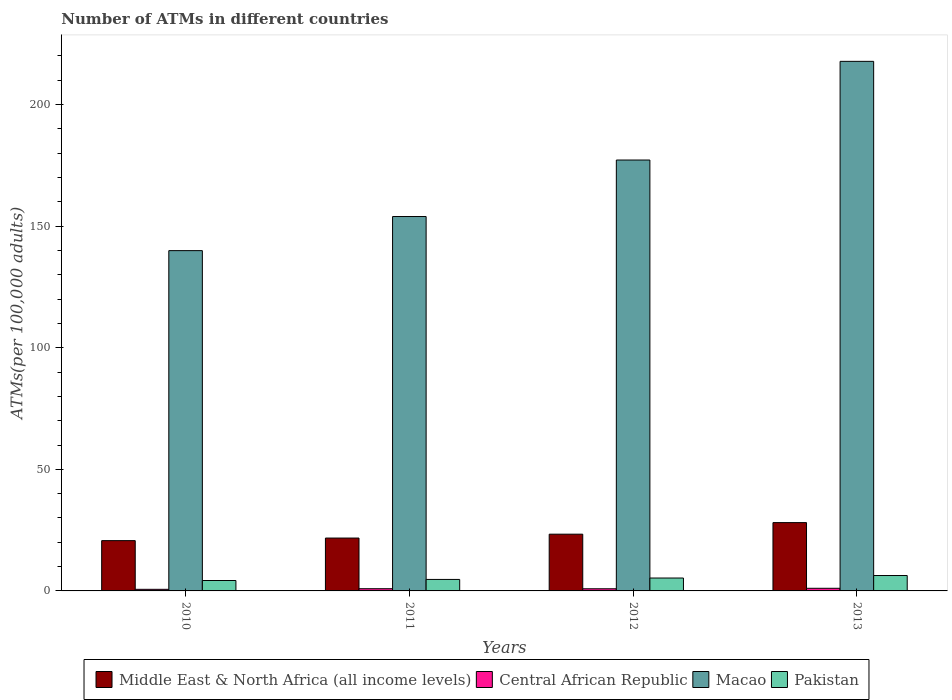How many different coloured bars are there?
Your response must be concise. 4. How many groups of bars are there?
Offer a terse response. 4. Are the number of bars per tick equal to the number of legend labels?
Offer a terse response. Yes. Are the number of bars on each tick of the X-axis equal?
Give a very brief answer. Yes. How many bars are there on the 4th tick from the left?
Give a very brief answer. 4. What is the label of the 2nd group of bars from the left?
Offer a very short reply. 2011. What is the number of ATMs in Pakistan in 2011?
Your response must be concise. 4.73. Across all years, what is the maximum number of ATMs in Central African Republic?
Provide a short and direct response. 1.08. Across all years, what is the minimum number of ATMs in Middle East & North Africa (all income levels)?
Keep it short and to the point. 20.68. In which year was the number of ATMs in Pakistan minimum?
Keep it short and to the point. 2010. What is the total number of ATMs in Central African Republic in the graph?
Make the answer very short. 3.53. What is the difference between the number of ATMs in Central African Republic in 2011 and that in 2012?
Give a very brief answer. 0.02. What is the difference between the number of ATMs in Central African Republic in 2011 and the number of ATMs in Pakistan in 2012?
Provide a short and direct response. -4.4. What is the average number of ATMs in Pakistan per year?
Offer a terse response. 5.16. In the year 2013, what is the difference between the number of ATMs in Middle East & North Africa (all income levels) and number of ATMs in Macao?
Provide a short and direct response. -189.7. In how many years, is the number of ATMs in Middle East & North Africa (all income levels) greater than 180?
Give a very brief answer. 0. What is the ratio of the number of ATMs in Central African Republic in 2010 to that in 2012?
Your response must be concise. 0.74. Is the number of ATMs in Central African Republic in 2011 less than that in 2012?
Keep it short and to the point. No. Is the difference between the number of ATMs in Middle East & North Africa (all income levels) in 2010 and 2012 greater than the difference between the number of ATMs in Macao in 2010 and 2012?
Provide a succinct answer. Yes. What is the difference between the highest and the second highest number of ATMs in Central African Republic?
Provide a succinct answer. 0.17. What is the difference between the highest and the lowest number of ATMs in Central African Republic?
Your response must be concise. 0.42. Is the sum of the number of ATMs in Central African Republic in 2010 and 2011 greater than the maximum number of ATMs in Pakistan across all years?
Make the answer very short. No. What does the 3rd bar from the left in 2013 represents?
Your answer should be compact. Macao. Are all the bars in the graph horizontal?
Provide a short and direct response. No. What is the difference between two consecutive major ticks on the Y-axis?
Offer a terse response. 50. Are the values on the major ticks of Y-axis written in scientific E-notation?
Ensure brevity in your answer.  No. Does the graph contain any zero values?
Provide a succinct answer. No. Where does the legend appear in the graph?
Your response must be concise. Bottom center. How many legend labels are there?
Your answer should be very brief. 4. What is the title of the graph?
Your answer should be compact. Number of ATMs in different countries. Does "Equatorial Guinea" appear as one of the legend labels in the graph?
Make the answer very short. No. What is the label or title of the Y-axis?
Your answer should be compact. ATMs(per 100,0 adults). What is the ATMs(per 100,000 adults) of Middle East & North Africa (all income levels) in 2010?
Give a very brief answer. 20.68. What is the ATMs(per 100,000 adults) of Central African Republic in 2010?
Provide a short and direct response. 0.66. What is the ATMs(per 100,000 adults) in Macao in 2010?
Your answer should be very brief. 139.95. What is the ATMs(per 100,000 adults) in Pakistan in 2010?
Your answer should be compact. 4.28. What is the ATMs(per 100,000 adults) of Middle East & North Africa (all income levels) in 2011?
Keep it short and to the point. 21.74. What is the ATMs(per 100,000 adults) in Central African Republic in 2011?
Keep it short and to the point. 0.91. What is the ATMs(per 100,000 adults) in Macao in 2011?
Keep it short and to the point. 153.98. What is the ATMs(per 100,000 adults) of Pakistan in 2011?
Give a very brief answer. 4.73. What is the ATMs(per 100,000 adults) in Middle East & North Africa (all income levels) in 2012?
Your answer should be compact. 23.34. What is the ATMs(per 100,000 adults) of Central African Republic in 2012?
Offer a very short reply. 0.88. What is the ATMs(per 100,000 adults) in Macao in 2012?
Offer a terse response. 177.21. What is the ATMs(per 100,000 adults) of Pakistan in 2012?
Make the answer very short. 5.31. What is the ATMs(per 100,000 adults) of Middle East & North Africa (all income levels) in 2013?
Ensure brevity in your answer.  28.1. What is the ATMs(per 100,000 adults) of Central African Republic in 2013?
Ensure brevity in your answer.  1.08. What is the ATMs(per 100,000 adults) of Macao in 2013?
Offer a terse response. 217.79. What is the ATMs(per 100,000 adults) of Pakistan in 2013?
Offer a very short reply. 6.33. Across all years, what is the maximum ATMs(per 100,000 adults) in Middle East & North Africa (all income levels)?
Provide a succinct answer. 28.1. Across all years, what is the maximum ATMs(per 100,000 adults) in Central African Republic?
Your response must be concise. 1.08. Across all years, what is the maximum ATMs(per 100,000 adults) in Macao?
Provide a short and direct response. 217.79. Across all years, what is the maximum ATMs(per 100,000 adults) of Pakistan?
Offer a terse response. 6.33. Across all years, what is the minimum ATMs(per 100,000 adults) of Middle East & North Africa (all income levels)?
Your response must be concise. 20.68. Across all years, what is the minimum ATMs(per 100,000 adults) in Central African Republic?
Keep it short and to the point. 0.66. Across all years, what is the minimum ATMs(per 100,000 adults) of Macao?
Make the answer very short. 139.95. Across all years, what is the minimum ATMs(per 100,000 adults) in Pakistan?
Your response must be concise. 4.28. What is the total ATMs(per 100,000 adults) in Middle East & North Africa (all income levels) in the graph?
Your response must be concise. 93.86. What is the total ATMs(per 100,000 adults) in Central African Republic in the graph?
Your response must be concise. 3.53. What is the total ATMs(per 100,000 adults) in Macao in the graph?
Offer a terse response. 688.93. What is the total ATMs(per 100,000 adults) in Pakistan in the graph?
Your answer should be compact. 20.65. What is the difference between the ATMs(per 100,000 adults) of Middle East & North Africa (all income levels) in 2010 and that in 2011?
Give a very brief answer. -1.06. What is the difference between the ATMs(per 100,000 adults) of Central African Republic in 2010 and that in 2011?
Offer a terse response. -0.25. What is the difference between the ATMs(per 100,000 adults) of Macao in 2010 and that in 2011?
Offer a very short reply. -14.03. What is the difference between the ATMs(per 100,000 adults) in Pakistan in 2010 and that in 2011?
Offer a terse response. -0.45. What is the difference between the ATMs(per 100,000 adults) of Middle East & North Africa (all income levels) in 2010 and that in 2012?
Your answer should be very brief. -2.65. What is the difference between the ATMs(per 100,000 adults) in Central African Republic in 2010 and that in 2012?
Offer a terse response. -0.23. What is the difference between the ATMs(per 100,000 adults) of Macao in 2010 and that in 2012?
Make the answer very short. -37.27. What is the difference between the ATMs(per 100,000 adults) of Pakistan in 2010 and that in 2012?
Give a very brief answer. -1.02. What is the difference between the ATMs(per 100,000 adults) of Middle East & North Africa (all income levels) in 2010 and that in 2013?
Offer a terse response. -7.41. What is the difference between the ATMs(per 100,000 adults) of Central African Republic in 2010 and that in 2013?
Provide a succinct answer. -0.42. What is the difference between the ATMs(per 100,000 adults) of Macao in 2010 and that in 2013?
Your answer should be compact. -77.85. What is the difference between the ATMs(per 100,000 adults) of Pakistan in 2010 and that in 2013?
Offer a terse response. -2.05. What is the difference between the ATMs(per 100,000 adults) in Middle East & North Africa (all income levels) in 2011 and that in 2012?
Keep it short and to the point. -1.59. What is the difference between the ATMs(per 100,000 adults) of Central African Republic in 2011 and that in 2012?
Make the answer very short. 0.02. What is the difference between the ATMs(per 100,000 adults) in Macao in 2011 and that in 2012?
Provide a short and direct response. -23.24. What is the difference between the ATMs(per 100,000 adults) of Pakistan in 2011 and that in 2012?
Give a very brief answer. -0.58. What is the difference between the ATMs(per 100,000 adults) in Middle East & North Africa (all income levels) in 2011 and that in 2013?
Make the answer very short. -6.35. What is the difference between the ATMs(per 100,000 adults) in Central African Republic in 2011 and that in 2013?
Your answer should be compact. -0.17. What is the difference between the ATMs(per 100,000 adults) in Macao in 2011 and that in 2013?
Give a very brief answer. -63.82. What is the difference between the ATMs(per 100,000 adults) of Pakistan in 2011 and that in 2013?
Provide a succinct answer. -1.61. What is the difference between the ATMs(per 100,000 adults) of Middle East & North Africa (all income levels) in 2012 and that in 2013?
Provide a succinct answer. -4.76. What is the difference between the ATMs(per 100,000 adults) in Central African Republic in 2012 and that in 2013?
Provide a succinct answer. -0.2. What is the difference between the ATMs(per 100,000 adults) in Macao in 2012 and that in 2013?
Give a very brief answer. -40.58. What is the difference between the ATMs(per 100,000 adults) in Pakistan in 2012 and that in 2013?
Offer a very short reply. -1.03. What is the difference between the ATMs(per 100,000 adults) in Middle East & North Africa (all income levels) in 2010 and the ATMs(per 100,000 adults) in Central African Republic in 2011?
Provide a succinct answer. 19.78. What is the difference between the ATMs(per 100,000 adults) of Middle East & North Africa (all income levels) in 2010 and the ATMs(per 100,000 adults) of Macao in 2011?
Provide a short and direct response. -133.29. What is the difference between the ATMs(per 100,000 adults) in Middle East & North Africa (all income levels) in 2010 and the ATMs(per 100,000 adults) in Pakistan in 2011?
Offer a very short reply. 15.96. What is the difference between the ATMs(per 100,000 adults) of Central African Republic in 2010 and the ATMs(per 100,000 adults) of Macao in 2011?
Your answer should be compact. -153.32. What is the difference between the ATMs(per 100,000 adults) in Central African Republic in 2010 and the ATMs(per 100,000 adults) in Pakistan in 2011?
Provide a short and direct response. -4.07. What is the difference between the ATMs(per 100,000 adults) of Macao in 2010 and the ATMs(per 100,000 adults) of Pakistan in 2011?
Ensure brevity in your answer.  135.22. What is the difference between the ATMs(per 100,000 adults) of Middle East & North Africa (all income levels) in 2010 and the ATMs(per 100,000 adults) of Central African Republic in 2012?
Offer a very short reply. 19.8. What is the difference between the ATMs(per 100,000 adults) in Middle East & North Africa (all income levels) in 2010 and the ATMs(per 100,000 adults) in Macao in 2012?
Your answer should be compact. -156.53. What is the difference between the ATMs(per 100,000 adults) of Middle East & North Africa (all income levels) in 2010 and the ATMs(per 100,000 adults) of Pakistan in 2012?
Your response must be concise. 15.38. What is the difference between the ATMs(per 100,000 adults) in Central African Republic in 2010 and the ATMs(per 100,000 adults) in Macao in 2012?
Your answer should be compact. -176.56. What is the difference between the ATMs(per 100,000 adults) of Central African Republic in 2010 and the ATMs(per 100,000 adults) of Pakistan in 2012?
Provide a succinct answer. -4.65. What is the difference between the ATMs(per 100,000 adults) of Macao in 2010 and the ATMs(per 100,000 adults) of Pakistan in 2012?
Offer a very short reply. 134.64. What is the difference between the ATMs(per 100,000 adults) of Middle East & North Africa (all income levels) in 2010 and the ATMs(per 100,000 adults) of Central African Republic in 2013?
Provide a succinct answer. 19.6. What is the difference between the ATMs(per 100,000 adults) of Middle East & North Africa (all income levels) in 2010 and the ATMs(per 100,000 adults) of Macao in 2013?
Ensure brevity in your answer.  -197.11. What is the difference between the ATMs(per 100,000 adults) in Middle East & North Africa (all income levels) in 2010 and the ATMs(per 100,000 adults) in Pakistan in 2013?
Give a very brief answer. 14.35. What is the difference between the ATMs(per 100,000 adults) in Central African Republic in 2010 and the ATMs(per 100,000 adults) in Macao in 2013?
Give a very brief answer. -217.13. What is the difference between the ATMs(per 100,000 adults) in Central African Republic in 2010 and the ATMs(per 100,000 adults) in Pakistan in 2013?
Your answer should be very brief. -5.68. What is the difference between the ATMs(per 100,000 adults) in Macao in 2010 and the ATMs(per 100,000 adults) in Pakistan in 2013?
Give a very brief answer. 133.61. What is the difference between the ATMs(per 100,000 adults) in Middle East & North Africa (all income levels) in 2011 and the ATMs(per 100,000 adults) in Central African Republic in 2012?
Offer a terse response. 20.86. What is the difference between the ATMs(per 100,000 adults) of Middle East & North Africa (all income levels) in 2011 and the ATMs(per 100,000 adults) of Macao in 2012?
Your response must be concise. -155.47. What is the difference between the ATMs(per 100,000 adults) of Middle East & North Africa (all income levels) in 2011 and the ATMs(per 100,000 adults) of Pakistan in 2012?
Make the answer very short. 16.44. What is the difference between the ATMs(per 100,000 adults) in Central African Republic in 2011 and the ATMs(per 100,000 adults) in Macao in 2012?
Your response must be concise. -176.31. What is the difference between the ATMs(per 100,000 adults) of Central African Republic in 2011 and the ATMs(per 100,000 adults) of Pakistan in 2012?
Your response must be concise. -4.4. What is the difference between the ATMs(per 100,000 adults) in Macao in 2011 and the ATMs(per 100,000 adults) in Pakistan in 2012?
Provide a succinct answer. 148.67. What is the difference between the ATMs(per 100,000 adults) of Middle East & North Africa (all income levels) in 2011 and the ATMs(per 100,000 adults) of Central African Republic in 2013?
Provide a short and direct response. 20.66. What is the difference between the ATMs(per 100,000 adults) in Middle East & North Africa (all income levels) in 2011 and the ATMs(per 100,000 adults) in Macao in 2013?
Your answer should be compact. -196.05. What is the difference between the ATMs(per 100,000 adults) in Middle East & North Africa (all income levels) in 2011 and the ATMs(per 100,000 adults) in Pakistan in 2013?
Offer a terse response. 15.41. What is the difference between the ATMs(per 100,000 adults) in Central African Republic in 2011 and the ATMs(per 100,000 adults) in Macao in 2013?
Make the answer very short. -216.88. What is the difference between the ATMs(per 100,000 adults) of Central African Republic in 2011 and the ATMs(per 100,000 adults) of Pakistan in 2013?
Make the answer very short. -5.43. What is the difference between the ATMs(per 100,000 adults) in Macao in 2011 and the ATMs(per 100,000 adults) in Pakistan in 2013?
Make the answer very short. 147.64. What is the difference between the ATMs(per 100,000 adults) of Middle East & North Africa (all income levels) in 2012 and the ATMs(per 100,000 adults) of Central African Republic in 2013?
Your response must be concise. 22.26. What is the difference between the ATMs(per 100,000 adults) of Middle East & North Africa (all income levels) in 2012 and the ATMs(per 100,000 adults) of Macao in 2013?
Make the answer very short. -194.46. What is the difference between the ATMs(per 100,000 adults) in Middle East & North Africa (all income levels) in 2012 and the ATMs(per 100,000 adults) in Pakistan in 2013?
Ensure brevity in your answer.  17. What is the difference between the ATMs(per 100,000 adults) in Central African Republic in 2012 and the ATMs(per 100,000 adults) in Macao in 2013?
Your answer should be compact. -216.91. What is the difference between the ATMs(per 100,000 adults) in Central African Republic in 2012 and the ATMs(per 100,000 adults) in Pakistan in 2013?
Your answer should be very brief. -5.45. What is the difference between the ATMs(per 100,000 adults) of Macao in 2012 and the ATMs(per 100,000 adults) of Pakistan in 2013?
Make the answer very short. 170.88. What is the average ATMs(per 100,000 adults) of Middle East & North Africa (all income levels) per year?
Make the answer very short. 23.46. What is the average ATMs(per 100,000 adults) in Central African Republic per year?
Provide a succinct answer. 0.88. What is the average ATMs(per 100,000 adults) of Macao per year?
Give a very brief answer. 172.23. What is the average ATMs(per 100,000 adults) of Pakistan per year?
Provide a succinct answer. 5.16. In the year 2010, what is the difference between the ATMs(per 100,000 adults) in Middle East & North Africa (all income levels) and ATMs(per 100,000 adults) in Central African Republic?
Your response must be concise. 20.02. In the year 2010, what is the difference between the ATMs(per 100,000 adults) in Middle East & North Africa (all income levels) and ATMs(per 100,000 adults) in Macao?
Your answer should be very brief. -119.26. In the year 2010, what is the difference between the ATMs(per 100,000 adults) in Middle East & North Africa (all income levels) and ATMs(per 100,000 adults) in Pakistan?
Provide a short and direct response. 16.4. In the year 2010, what is the difference between the ATMs(per 100,000 adults) of Central African Republic and ATMs(per 100,000 adults) of Macao?
Give a very brief answer. -139.29. In the year 2010, what is the difference between the ATMs(per 100,000 adults) of Central African Republic and ATMs(per 100,000 adults) of Pakistan?
Provide a short and direct response. -3.62. In the year 2010, what is the difference between the ATMs(per 100,000 adults) of Macao and ATMs(per 100,000 adults) of Pakistan?
Provide a short and direct response. 135.66. In the year 2011, what is the difference between the ATMs(per 100,000 adults) of Middle East & North Africa (all income levels) and ATMs(per 100,000 adults) of Central African Republic?
Your response must be concise. 20.83. In the year 2011, what is the difference between the ATMs(per 100,000 adults) of Middle East & North Africa (all income levels) and ATMs(per 100,000 adults) of Macao?
Offer a very short reply. -132.23. In the year 2011, what is the difference between the ATMs(per 100,000 adults) of Middle East & North Africa (all income levels) and ATMs(per 100,000 adults) of Pakistan?
Your answer should be compact. 17.01. In the year 2011, what is the difference between the ATMs(per 100,000 adults) of Central African Republic and ATMs(per 100,000 adults) of Macao?
Your answer should be compact. -153.07. In the year 2011, what is the difference between the ATMs(per 100,000 adults) in Central African Republic and ATMs(per 100,000 adults) in Pakistan?
Your answer should be very brief. -3.82. In the year 2011, what is the difference between the ATMs(per 100,000 adults) of Macao and ATMs(per 100,000 adults) of Pakistan?
Make the answer very short. 149.25. In the year 2012, what is the difference between the ATMs(per 100,000 adults) in Middle East & North Africa (all income levels) and ATMs(per 100,000 adults) in Central African Republic?
Your answer should be compact. 22.45. In the year 2012, what is the difference between the ATMs(per 100,000 adults) in Middle East & North Africa (all income levels) and ATMs(per 100,000 adults) in Macao?
Provide a succinct answer. -153.88. In the year 2012, what is the difference between the ATMs(per 100,000 adults) of Middle East & North Africa (all income levels) and ATMs(per 100,000 adults) of Pakistan?
Ensure brevity in your answer.  18.03. In the year 2012, what is the difference between the ATMs(per 100,000 adults) of Central African Republic and ATMs(per 100,000 adults) of Macao?
Keep it short and to the point. -176.33. In the year 2012, what is the difference between the ATMs(per 100,000 adults) in Central African Republic and ATMs(per 100,000 adults) in Pakistan?
Provide a succinct answer. -4.42. In the year 2012, what is the difference between the ATMs(per 100,000 adults) in Macao and ATMs(per 100,000 adults) in Pakistan?
Give a very brief answer. 171.91. In the year 2013, what is the difference between the ATMs(per 100,000 adults) in Middle East & North Africa (all income levels) and ATMs(per 100,000 adults) in Central African Republic?
Provide a short and direct response. 27.02. In the year 2013, what is the difference between the ATMs(per 100,000 adults) of Middle East & North Africa (all income levels) and ATMs(per 100,000 adults) of Macao?
Offer a terse response. -189.7. In the year 2013, what is the difference between the ATMs(per 100,000 adults) in Middle East & North Africa (all income levels) and ATMs(per 100,000 adults) in Pakistan?
Give a very brief answer. 21.76. In the year 2013, what is the difference between the ATMs(per 100,000 adults) in Central African Republic and ATMs(per 100,000 adults) in Macao?
Make the answer very short. -216.71. In the year 2013, what is the difference between the ATMs(per 100,000 adults) of Central African Republic and ATMs(per 100,000 adults) of Pakistan?
Give a very brief answer. -5.25. In the year 2013, what is the difference between the ATMs(per 100,000 adults) of Macao and ATMs(per 100,000 adults) of Pakistan?
Your response must be concise. 211.46. What is the ratio of the ATMs(per 100,000 adults) in Middle East & North Africa (all income levels) in 2010 to that in 2011?
Ensure brevity in your answer.  0.95. What is the ratio of the ATMs(per 100,000 adults) of Central African Republic in 2010 to that in 2011?
Offer a terse response. 0.73. What is the ratio of the ATMs(per 100,000 adults) in Macao in 2010 to that in 2011?
Provide a succinct answer. 0.91. What is the ratio of the ATMs(per 100,000 adults) in Pakistan in 2010 to that in 2011?
Keep it short and to the point. 0.91. What is the ratio of the ATMs(per 100,000 adults) of Middle East & North Africa (all income levels) in 2010 to that in 2012?
Give a very brief answer. 0.89. What is the ratio of the ATMs(per 100,000 adults) of Central African Republic in 2010 to that in 2012?
Your response must be concise. 0.74. What is the ratio of the ATMs(per 100,000 adults) of Macao in 2010 to that in 2012?
Provide a succinct answer. 0.79. What is the ratio of the ATMs(per 100,000 adults) of Pakistan in 2010 to that in 2012?
Make the answer very short. 0.81. What is the ratio of the ATMs(per 100,000 adults) of Middle East & North Africa (all income levels) in 2010 to that in 2013?
Offer a terse response. 0.74. What is the ratio of the ATMs(per 100,000 adults) of Central African Republic in 2010 to that in 2013?
Your answer should be compact. 0.61. What is the ratio of the ATMs(per 100,000 adults) in Macao in 2010 to that in 2013?
Make the answer very short. 0.64. What is the ratio of the ATMs(per 100,000 adults) in Pakistan in 2010 to that in 2013?
Give a very brief answer. 0.68. What is the ratio of the ATMs(per 100,000 adults) of Middle East & North Africa (all income levels) in 2011 to that in 2012?
Provide a succinct answer. 0.93. What is the ratio of the ATMs(per 100,000 adults) in Central African Republic in 2011 to that in 2012?
Offer a very short reply. 1.03. What is the ratio of the ATMs(per 100,000 adults) of Macao in 2011 to that in 2012?
Your answer should be very brief. 0.87. What is the ratio of the ATMs(per 100,000 adults) of Pakistan in 2011 to that in 2012?
Offer a very short reply. 0.89. What is the ratio of the ATMs(per 100,000 adults) of Middle East & North Africa (all income levels) in 2011 to that in 2013?
Make the answer very short. 0.77. What is the ratio of the ATMs(per 100,000 adults) in Central African Republic in 2011 to that in 2013?
Your answer should be very brief. 0.84. What is the ratio of the ATMs(per 100,000 adults) of Macao in 2011 to that in 2013?
Offer a terse response. 0.71. What is the ratio of the ATMs(per 100,000 adults) in Pakistan in 2011 to that in 2013?
Make the answer very short. 0.75. What is the ratio of the ATMs(per 100,000 adults) in Middle East & North Africa (all income levels) in 2012 to that in 2013?
Keep it short and to the point. 0.83. What is the ratio of the ATMs(per 100,000 adults) of Central African Republic in 2012 to that in 2013?
Ensure brevity in your answer.  0.82. What is the ratio of the ATMs(per 100,000 adults) in Macao in 2012 to that in 2013?
Offer a very short reply. 0.81. What is the ratio of the ATMs(per 100,000 adults) of Pakistan in 2012 to that in 2013?
Keep it short and to the point. 0.84. What is the difference between the highest and the second highest ATMs(per 100,000 adults) of Middle East & North Africa (all income levels)?
Offer a terse response. 4.76. What is the difference between the highest and the second highest ATMs(per 100,000 adults) in Central African Republic?
Keep it short and to the point. 0.17. What is the difference between the highest and the second highest ATMs(per 100,000 adults) in Macao?
Ensure brevity in your answer.  40.58. What is the difference between the highest and the second highest ATMs(per 100,000 adults) in Pakistan?
Your response must be concise. 1.03. What is the difference between the highest and the lowest ATMs(per 100,000 adults) in Middle East & North Africa (all income levels)?
Keep it short and to the point. 7.41. What is the difference between the highest and the lowest ATMs(per 100,000 adults) in Central African Republic?
Your response must be concise. 0.42. What is the difference between the highest and the lowest ATMs(per 100,000 adults) in Macao?
Offer a terse response. 77.85. What is the difference between the highest and the lowest ATMs(per 100,000 adults) of Pakistan?
Your answer should be very brief. 2.05. 